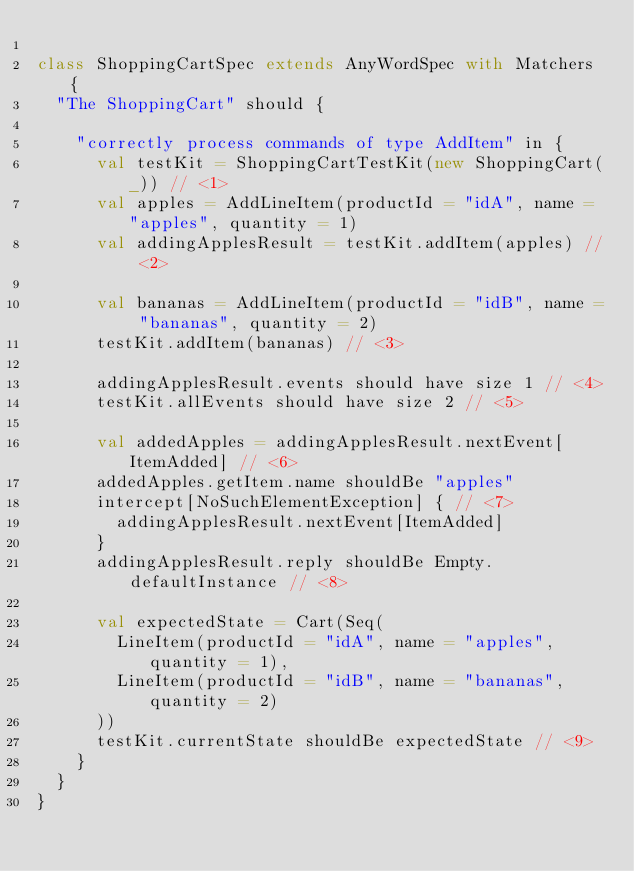<code> <loc_0><loc_0><loc_500><loc_500><_Scala_>
class ShoppingCartSpec extends AnyWordSpec with Matchers {
  "The ShoppingCart" should {

    "correctly process commands of type AddItem" in {
      val testKit = ShoppingCartTestKit(new ShoppingCart(_)) // <1>
      val apples = AddLineItem(productId = "idA", name = "apples", quantity = 1)
      val addingApplesResult = testKit.addItem(apples) // <2>

      val bananas = AddLineItem(productId = "idB", name = "bananas", quantity = 2)
      testKit.addItem(bananas) // <3>

      addingApplesResult.events should have size 1 // <4>
      testKit.allEvents should have size 2 // <5>

      val addedApples = addingApplesResult.nextEvent[ItemAdded] // <6>
      addedApples.getItem.name shouldBe "apples"
      intercept[NoSuchElementException] { // <7>
        addingApplesResult.nextEvent[ItemAdded]
      }
      addingApplesResult.reply shouldBe Empty.defaultInstance // <8>

      val expectedState = Cart(Seq(
        LineItem(productId = "idA", name = "apples", quantity = 1),
        LineItem(productId = "idB", name = "bananas", quantity = 2)
      ))
      testKit.currentState shouldBe expectedState // <9>
    }
  }
}
</code> 